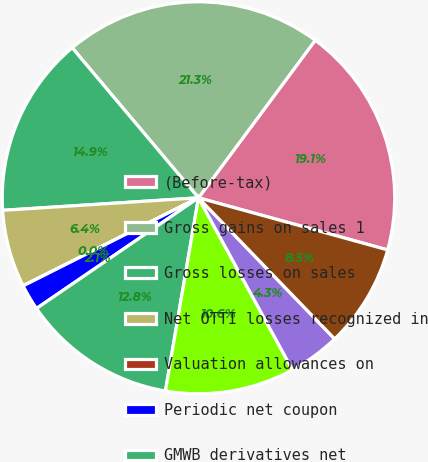Convert chart to OTSL. <chart><loc_0><loc_0><loc_500><loc_500><pie_chart><fcel>(Before-tax)<fcel>Gross gains on sales 1<fcel>Gross losses on sales<fcel>Net OTTI losses recognized in<fcel>Valuation allowances on<fcel>Periodic net coupon<fcel>GMWB derivatives net<fcel>Macro hedge program<fcel>Total results of variable<fcel>Other net 3<nl><fcel>19.14%<fcel>21.27%<fcel>14.89%<fcel>6.39%<fcel>0.01%<fcel>2.13%<fcel>12.76%<fcel>10.64%<fcel>4.26%<fcel>8.51%<nl></chart> 